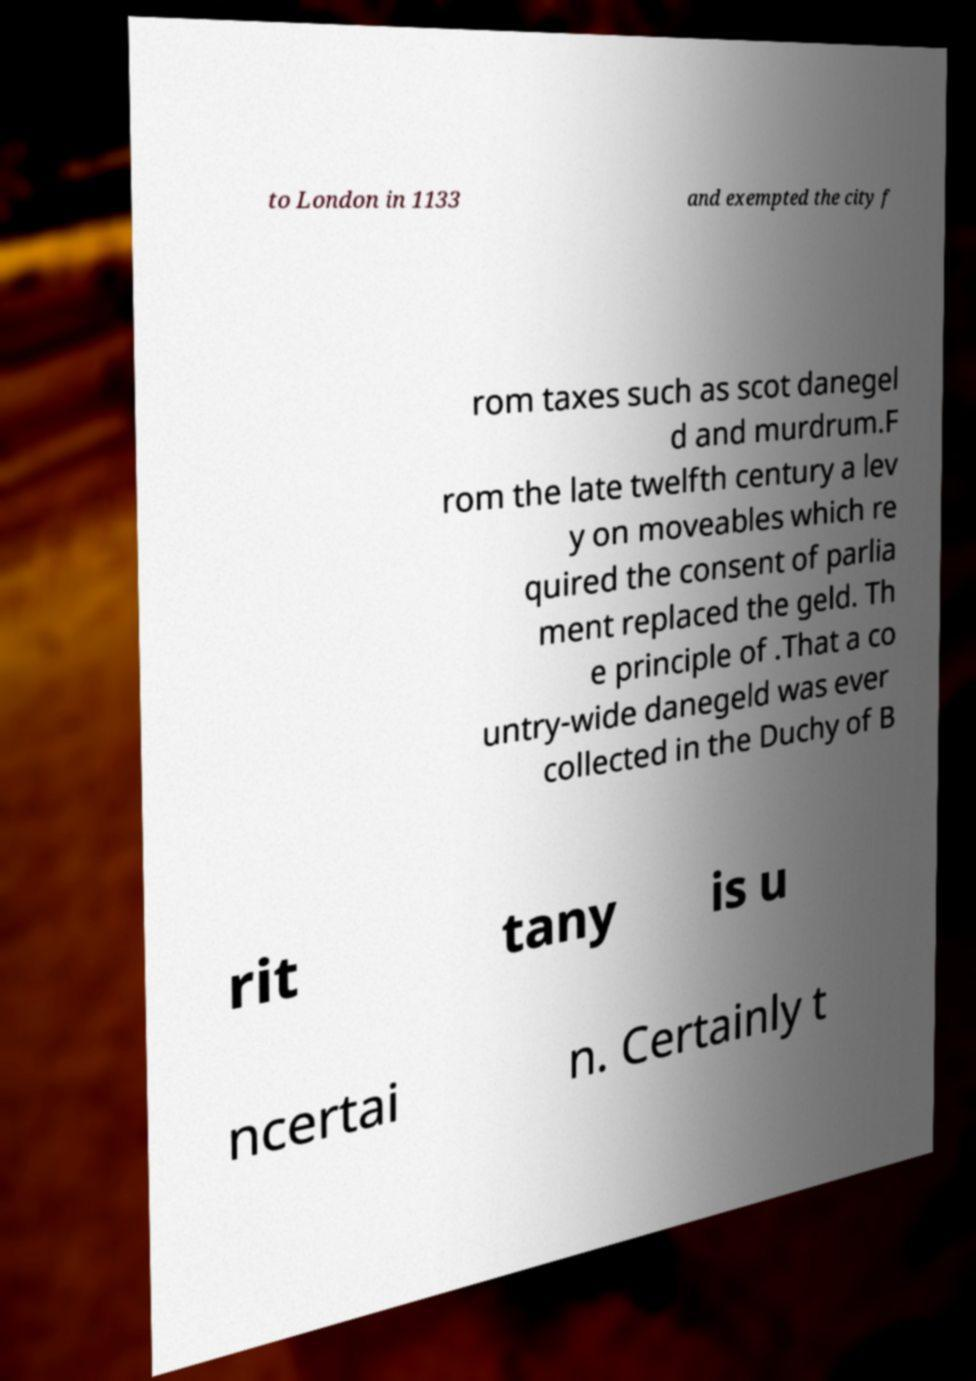Can you read and provide the text displayed in the image?This photo seems to have some interesting text. Can you extract and type it out for me? to London in 1133 and exempted the city f rom taxes such as scot danegel d and murdrum.F rom the late twelfth century a lev y on moveables which re quired the consent of parlia ment replaced the geld. Th e principle of .That a co untry-wide danegeld was ever collected in the Duchy of B rit tany is u ncertai n. Certainly t 